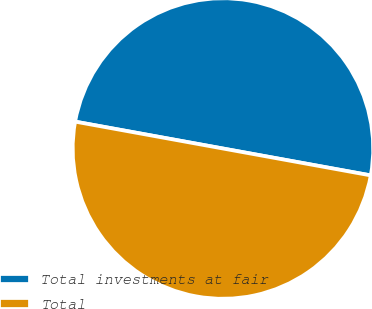Convert chart to OTSL. <chart><loc_0><loc_0><loc_500><loc_500><pie_chart><fcel>Total investments at fair<fcel>Total<nl><fcel>50.0%<fcel>50.0%<nl></chart> 